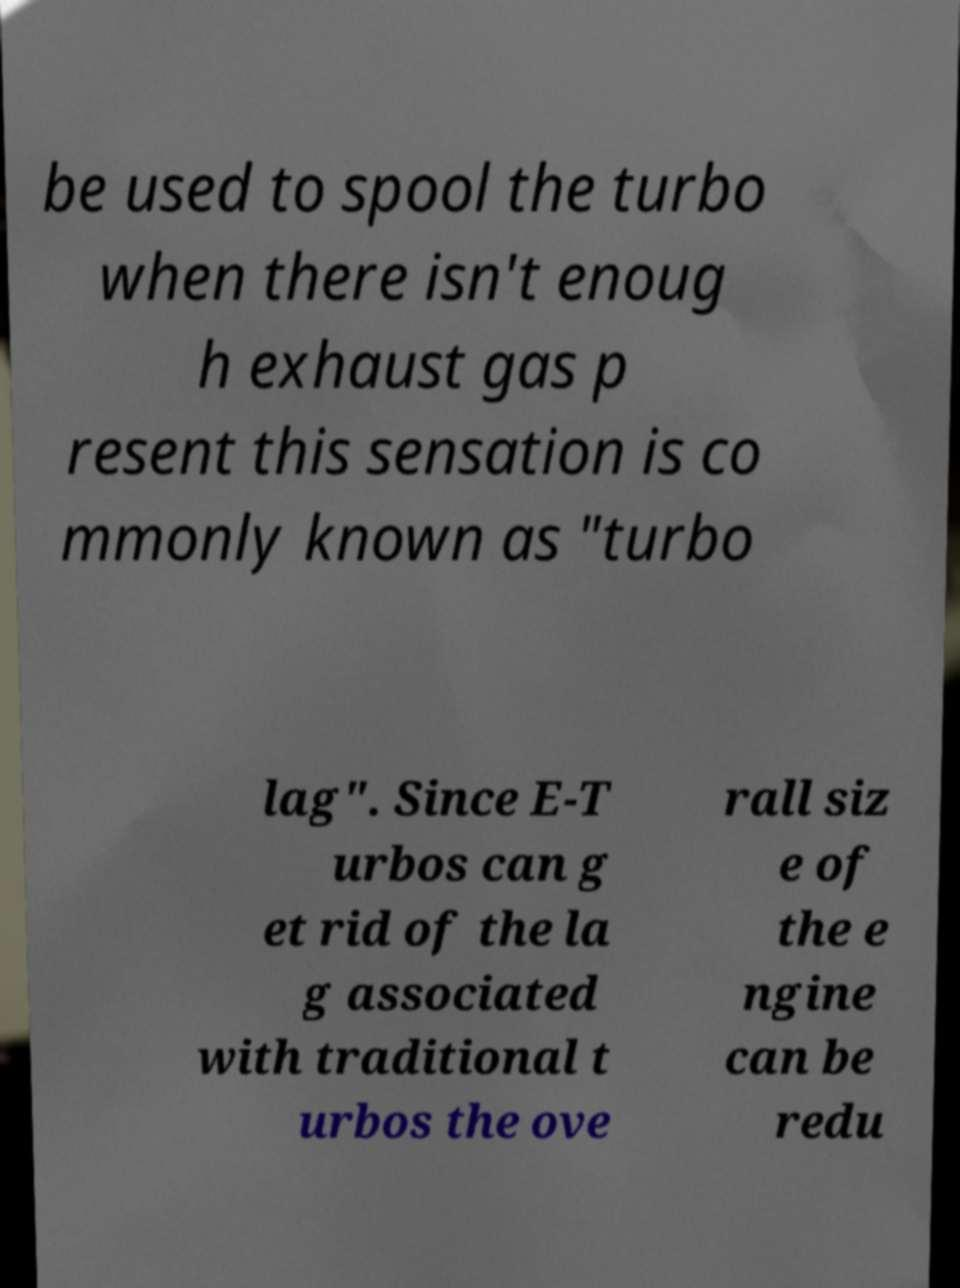Could you extract and type out the text from this image? be used to spool the turbo when there isn't enoug h exhaust gas p resent this sensation is co mmonly known as "turbo lag". Since E-T urbos can g et rid of the la g associated with traditional t urbos the ove rall siz e of the e ngine can be redu 